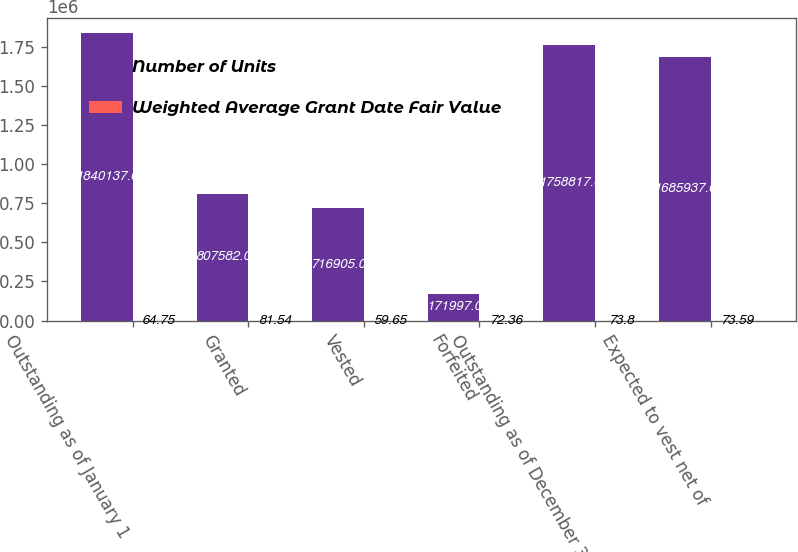<chart> <loc_0><loc_0><loc_500><loc_500><stacked_bar_chart><ecel><fcel>Outstanding as of January 1<fcel>Granted<fcel>Vested<fcel>Forfeited<fcel>Outstanding as of December 31<fcel>Expected to vest net of<nl><fcel>Number of Units<fcel>1.84014e+06<fcel>807582<fcel>716905<fcel>171997<fcel>1.75882e+06<fcel>1.68594e+06<nl><fcel>Weighted Average Grant Date Fair Value<fcel>64.75<fcel>81.54<fcel>59.65<fcel>72.36<fcel>73.8<fcel>73.59<nl></chart> 